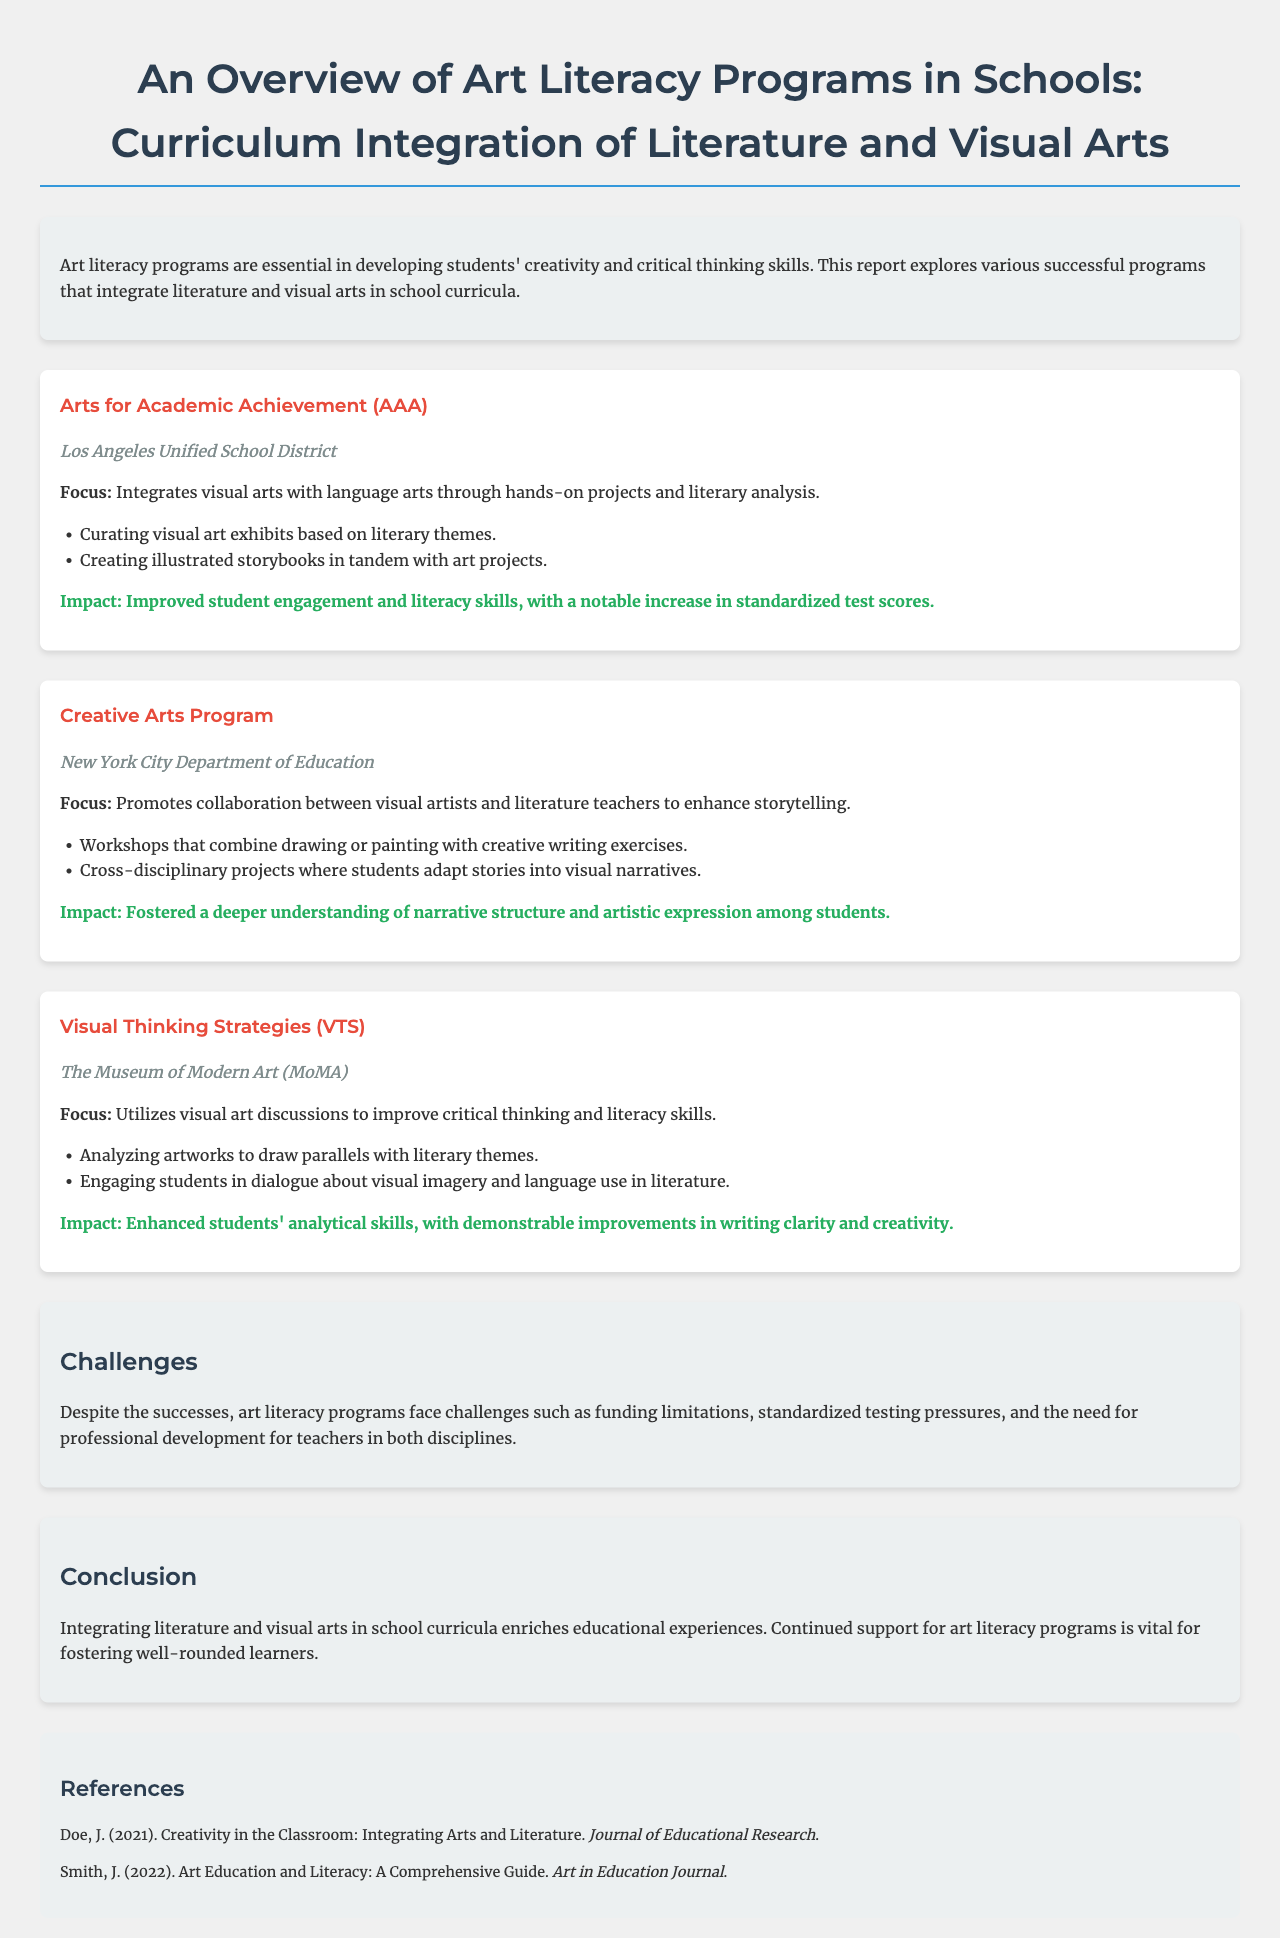What is the title of the report? The title can be found at the beginning of the document, outlining the main subject discussed.
Answer: An Overview of Art Literacy Programs in Schools: Curriculum Integration of Literature and Visual Arts Which program is associated with the Los Angeles Unified School District? The program details reveal specific organizations involved in art literacy initiatives, identifying their names and locations.
Answer: Arts for Academic Achievement (AAA) What is one key focus of the Creative Arts Program? The main focus of each program is provided, highlighting the integration strategies employed in the curriculum.
Answer: Collaboration between visual artists and literature teachers What impact did the Visual Thinking Strategies (VTS) have on students? The impacts of each program are mentioned, showcasing measurable outcomes from the initiatives implemented.
Answer: Enhanced students' analytical skills What is a common challenge faced by art literacy programs? The challenges facing these programs are summarized, indicating difficulties in their operation and implementation.
Answer: Funding limitations 